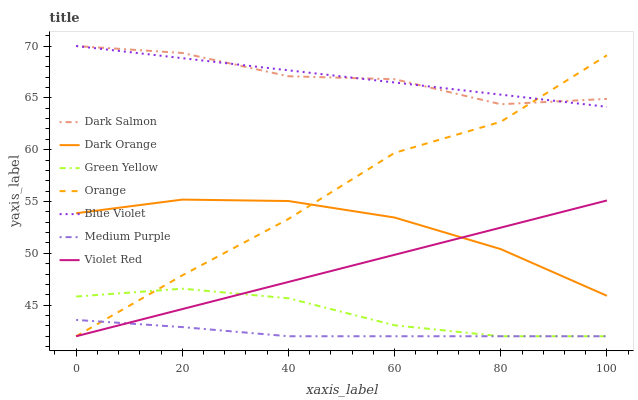Does Medium Purple have the minimum area under the curve?
Answer yes or no. Yes. Does Blue Violet have the maximum area under the curve?
Answer yes or no. Yes. Does Violet Red have the minimum area under the curve?
Answer yes or no. No. Does Violet Red have the maximum area under the curve?
Answer yes or no. No. Is Violet Red the smoothest?
Answer yes or no. Yes. Is Dark Salmon the roughest?
Answer yes or no. Yes. Is Dark Salmon the smoothest?
Answer yes or no. No. Is Violet Red the roughest?
Answer yes or no. No. Does Violet Red have the lowest value?
Answer yes or no. Yes. Does Dark Salmon have the lowest value?
Answer yes or no. No. Does Blue Violet have the highest value?
Answer yes or no. Yes. Does Violet Red have the highest value?
Answer yes or no. No. Is Green Yellow less than Blue Violet?
Answer yes or no. Yes. Is Dark Orange greater than Medium Purple?
Answer yes or no. Yes. Does Violet Red intersect Dark Orange?
Answer yes or no. Yes. Is Violet Red less than Dark Orange?
Answer yes or no. No. Is Violet Red greater than Dark Orange?
Answer yes or no. No. Does Green Yellow intersect Blue Violet?
Answer yes or no. No. 